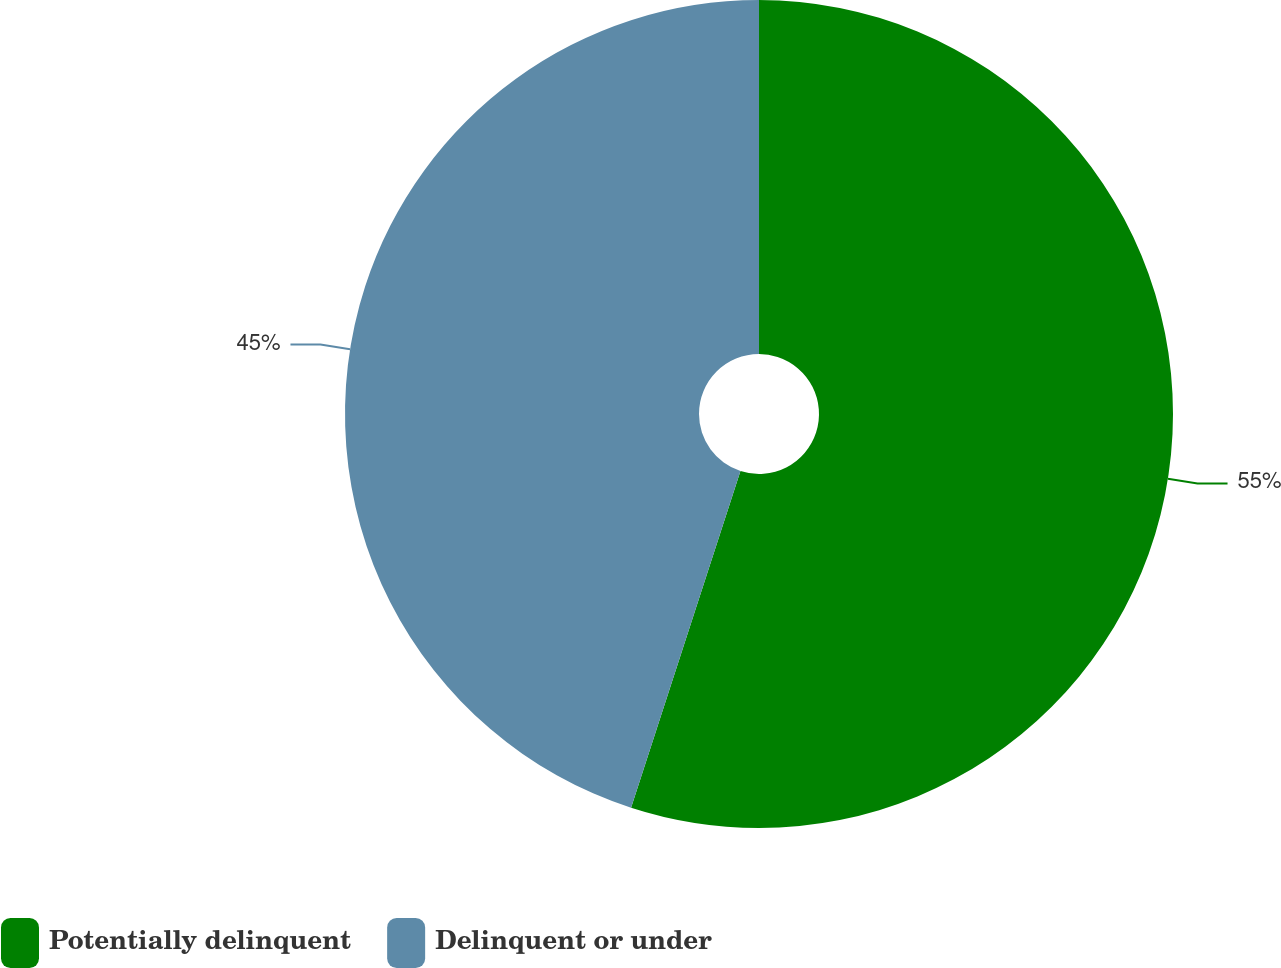Convert chart. <chart><loc_0><loc_0><loc_500><loc_500><pie_chart><fcel>Potentially delinquent<fcel>Delinquent or under<nl><fcel>55.0%<fcel>45.0%<nl></chart> 